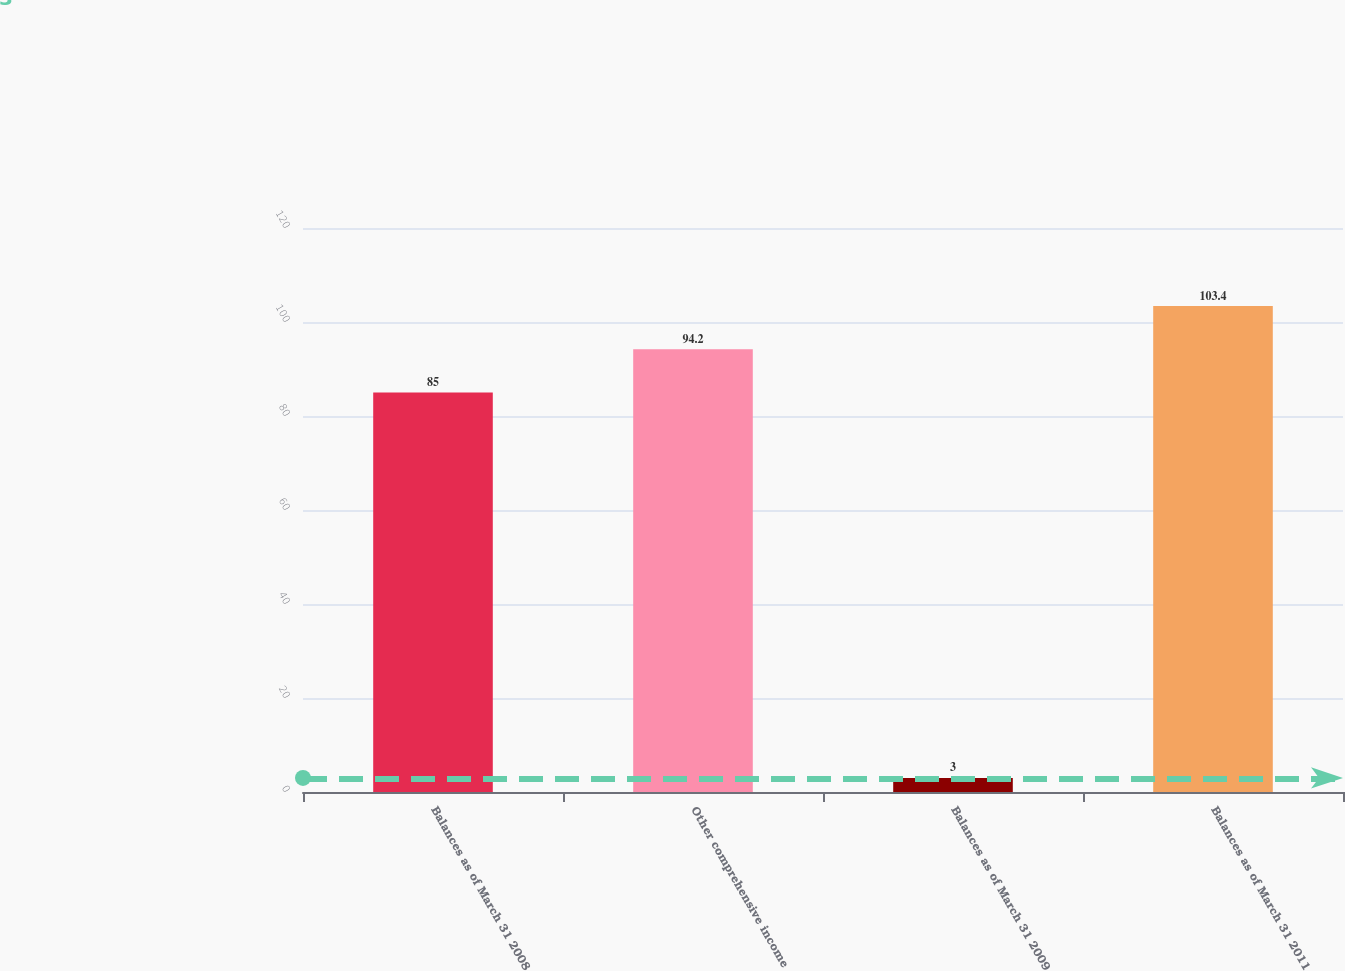Convert chart. <chart><loc_0><loc_0><loc_500><loc_500><bar_chart><fcel>Balances as of March 31 2008<fcel>Other comprehensive income<fcel>Balances as of March 31 2009<fcel>Balances as of March 31 2011<nl><fcel>85<fcel>94.2<fcel>3<fcel>103.4<nl></chart> 